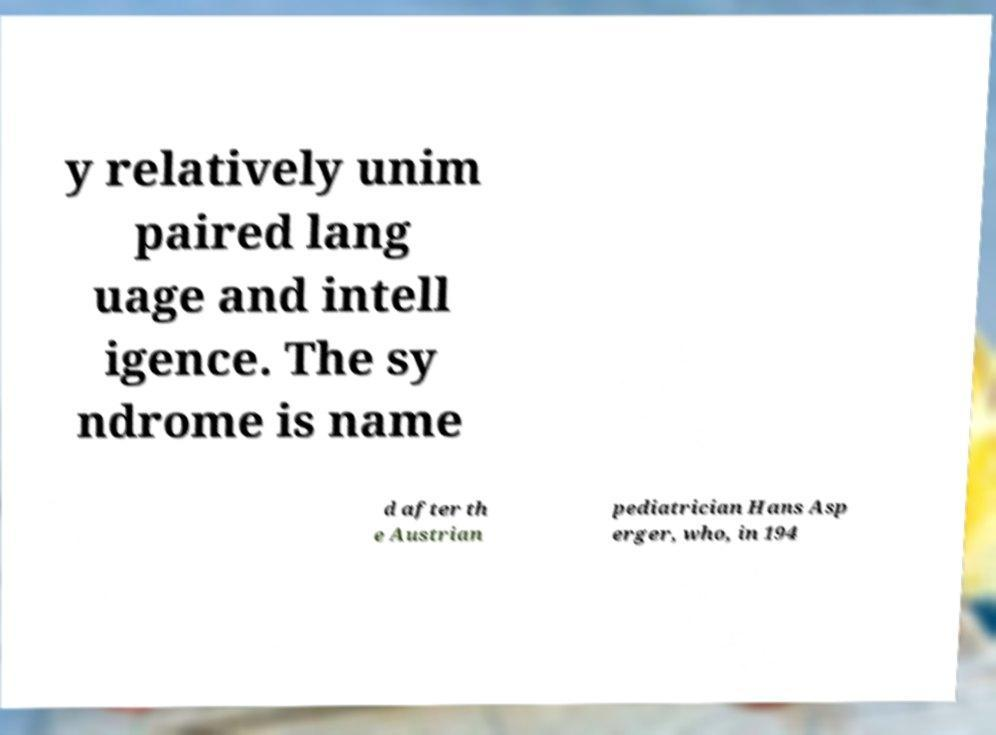Can you accurately transcribe the text from the provided image for me? y relatively unim paired lang uage and intell igence. The sy ndrome is name d after th e Austrian pediatrician Hans Asp erger, who, in 194 